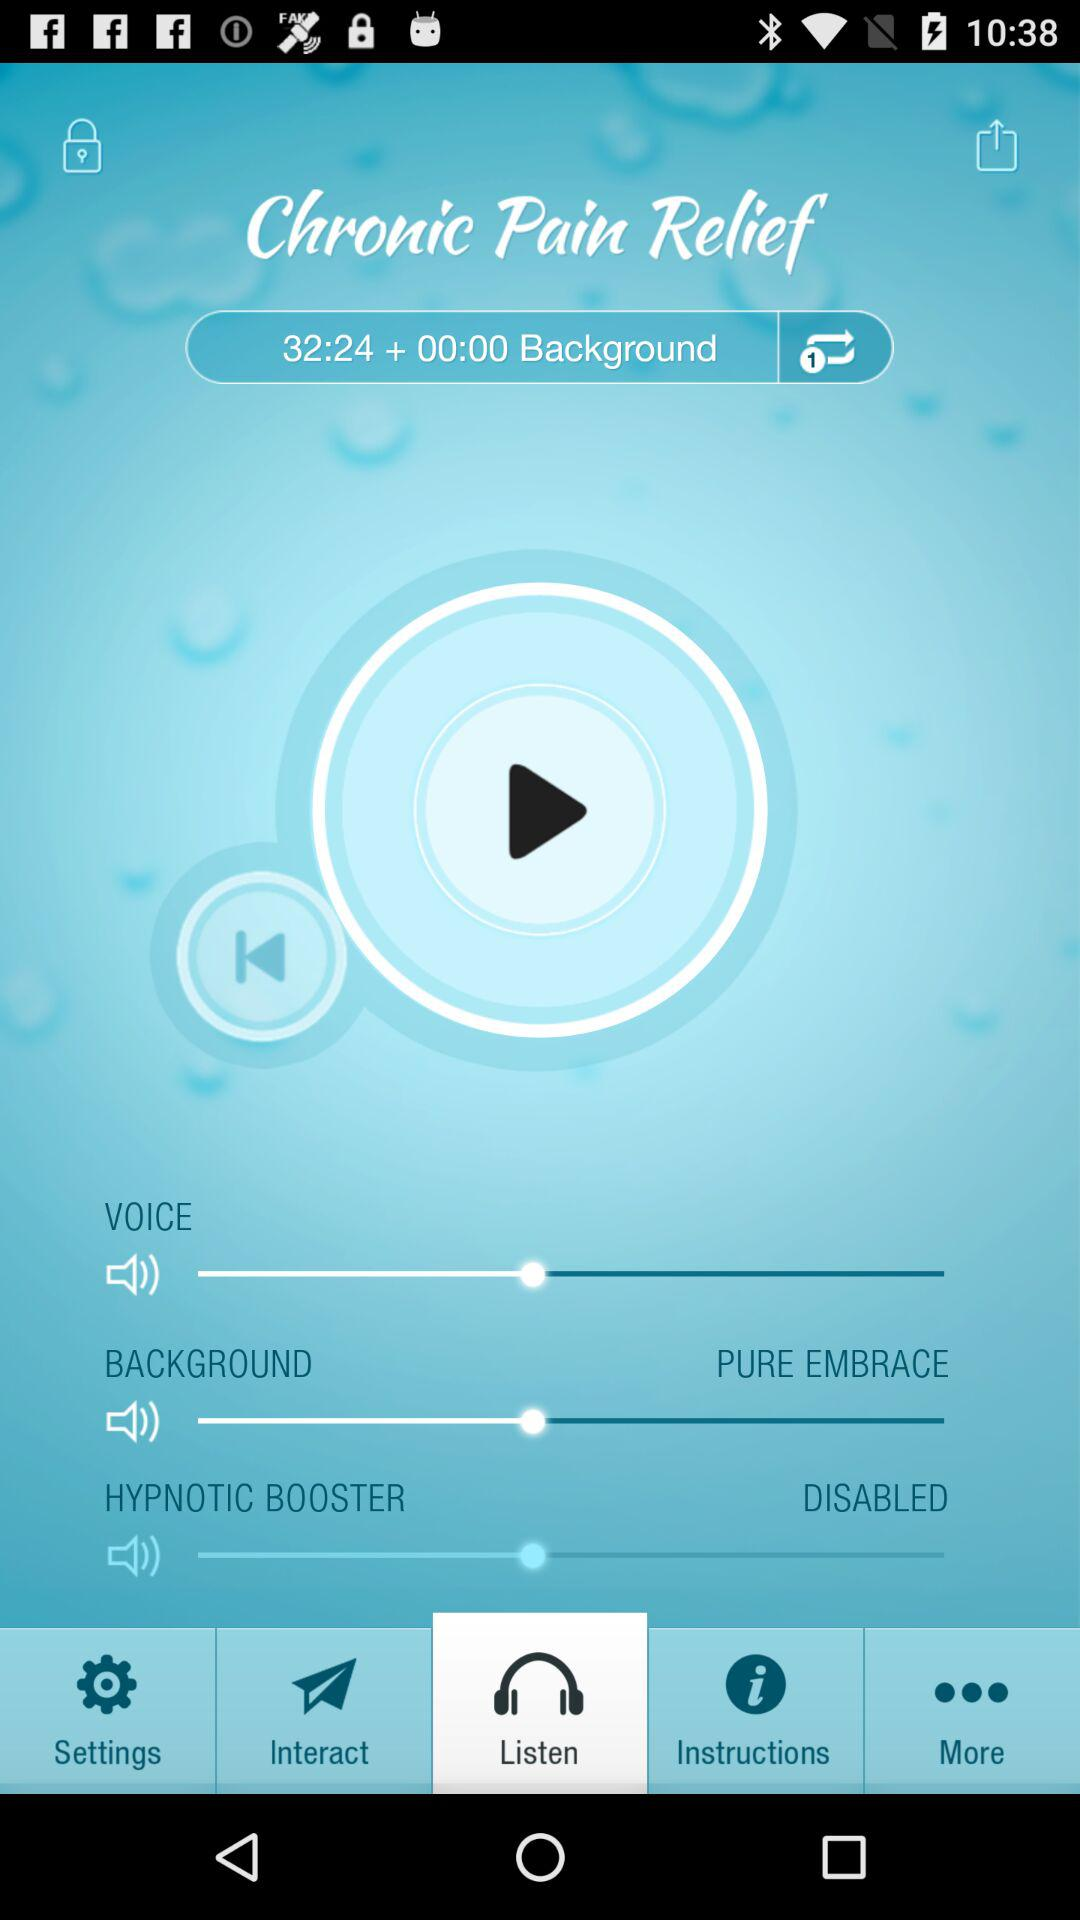What is the duration of the sound? The duration of the sound is 32:24 + 00:00. 